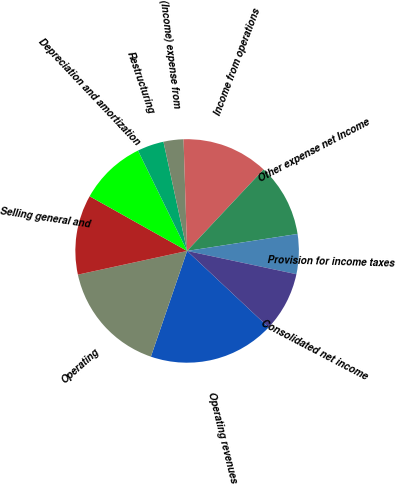Convert chart to OTSL. <chart><loc_0><loc_0><loc_500><loc_500><pie_chart><fcel>Operating revenues<fcel>Operating<fcel>Selling general and<fcel>Depreciation and amortization<fcel>Restructuring<fcel>(Income) expense from<fcel>Income from operations<fcel>Other expense net Income<fcel>Provision for income taxes<fcel>Consolidated net income<nl><fcel>18.27%<fcel>16.35%<fcel>11.54%<fcel>9.62%<fcel>3.85%<fcel>2.89%<fcel>12.5%<fcel>10.58%<fcel>5.77%<fcel>8.65%<nl></chart> 